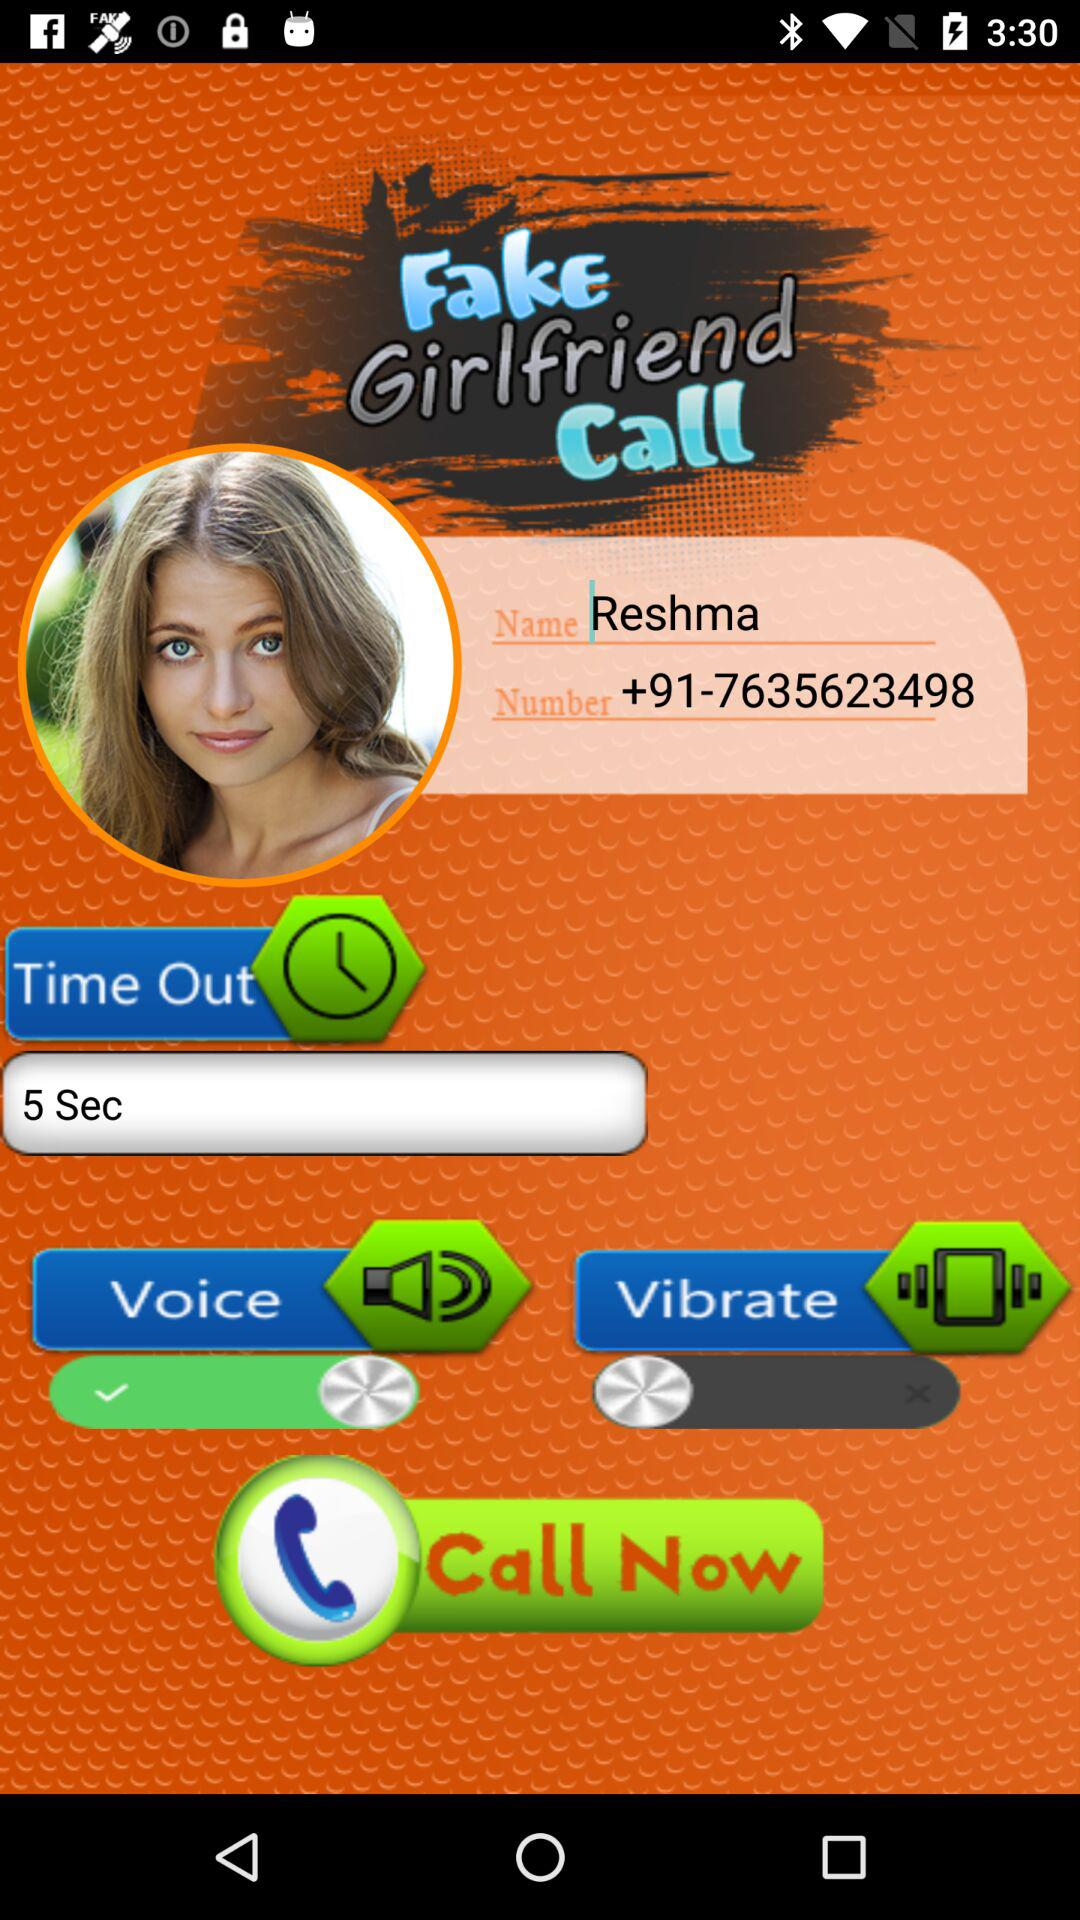What is the given name? The given name is Reshma. 